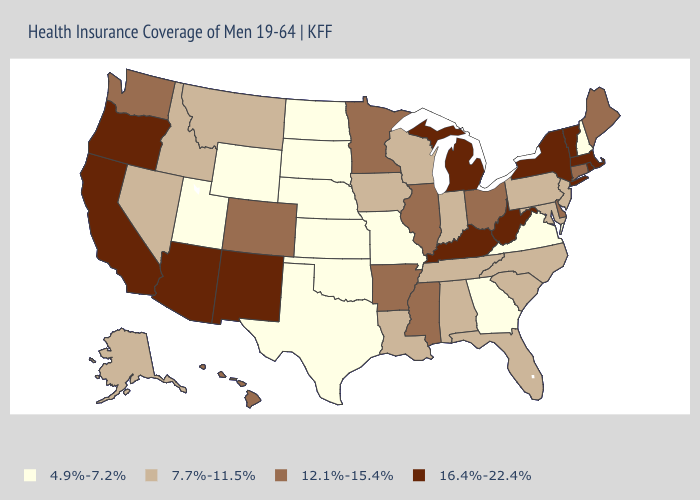What is the lowest value in states that border Kansas?
Be succinct. 4.9%-7.2%. Name the states that have a value in the range 4.9%-7.2%?
Write a very short answer. Georgia, Kansas, Missouri, Nebraska, New Hampshire, North Dakota, Oklahoma, South Dakota, Texas, Utah, Virginia, Wyoming. What is the highest value in the USA?
Answer briefly. 16.4%-22.4%. What is the value of Virginia?
Answer briefly. 4.9%-7.2%. What is the value of Virginia?
Keep it brief. 4.9%-7.2%. What is the value of Arkansas?
Quick response, please. 12.1%-15.4%. Name the states that have a value in the range 16.4%-22.4%?
Quick response, please. Arizona, California, Kentucky, Massachusetts, Michigan, New Mexico, New York, Oregon, Rhode Island, Vermont, West Virginia. Which states have the lowest value in the West?
Answer briefly. Utah, Wyoming. What is the value of Utah?
Answer briefly. 4.9%-7.2%. Does North Dakota have the lowest value in the USA?
Answer briefly. Yes. What is the value of Missouri?
Short answer required. 4.9%-7.2%. Name the states that have a value in the range 7.7%-11.5%?
Concise answer only. Alabama, Alaska, Florida, Idaho, Indiana, Iowa, Louisiana, Maryland, Montana, Nevada, New Jersey, North Carolina, Pennsylvania, South Carolina, Tennessee, Wisconsin. What is the lowest value in states that border Wyoming?
Keep it brief. 4.9%-7.2%. Does South Carolina have the highest value in the South?
Be succinct. No. What is the value of North Carolina?
Keep it brief. 7.7%-11.5%. 